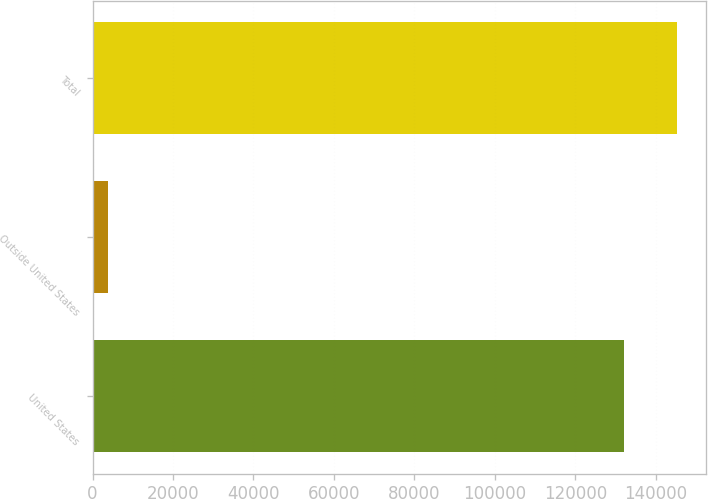Convert chart. <chart><loc_0><loc_0><loc_500><loc_500><bar_chart><fcel>United States<fcel>Outside United States<fcel>Total<nl><fcel>132056<fcel>3936<fcel>145262<nl></chart> 